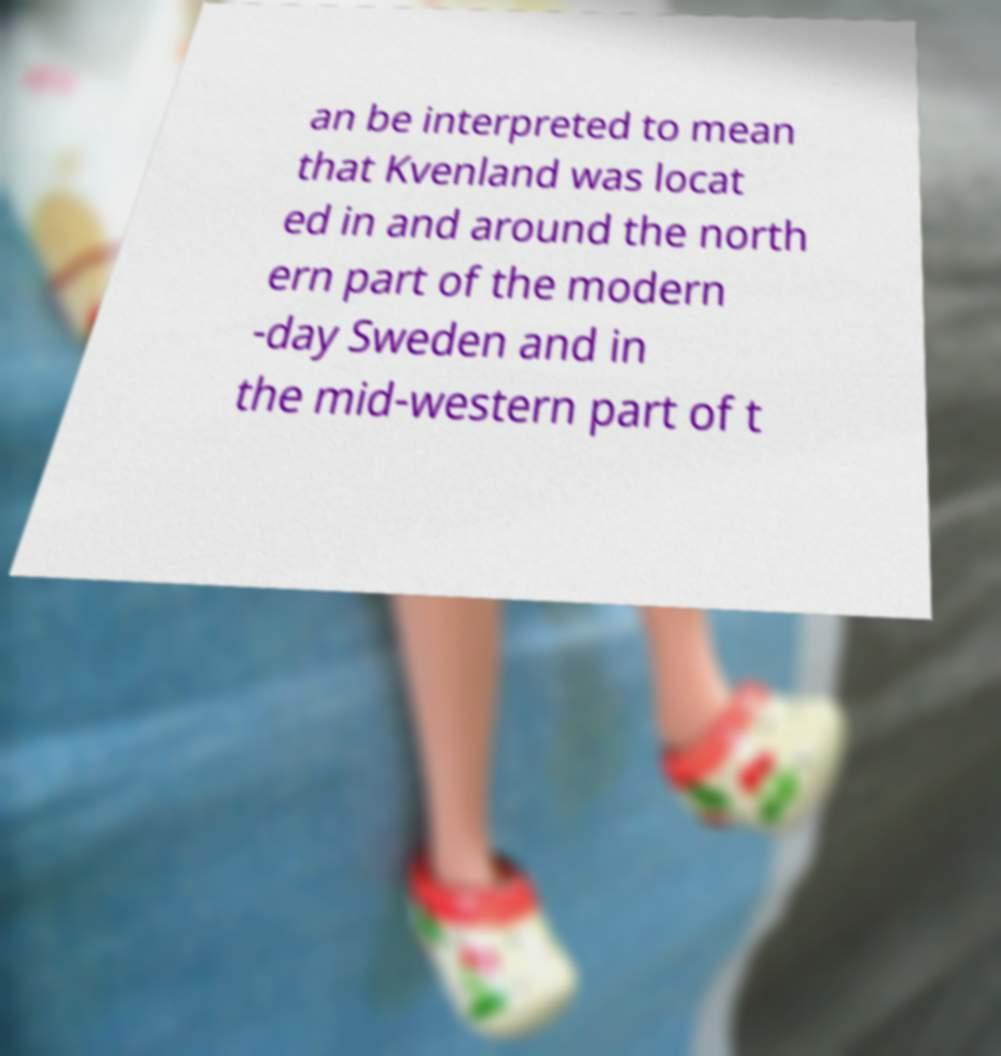I need the written content from this picture converted into text. Can you do that? an be interpreted to mean that Kvenland was locat ed in and around the north ern part of the modern -day Sweden and in the mid-western part of t 